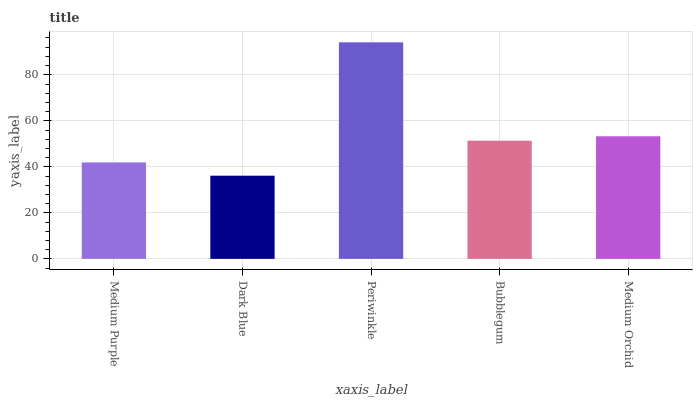Is Dark Blue the minimum?
Answer yes or no. Yes. Is Periwinkle the maximum?
Answer yes or no. Yes. Is Periwinkle the minimum?
Answer yes or no. No. Is Dark Blue the maximum?
Answer yes or no. No. Is Periwinkle greater than Dark Blue?
Answer yes or no. Yes. Is Dark Blue less than Periwinkle?
Answer yes or no. Yes. Is Dark Blue greater than Periwinkle?
Answer yes or no. No. Is Periwinkle less than Dark Blue?
Answer yes or no. No. Is Bubblegum the high median?
Answer yes or no. Yes. Is Bubblegum the low median?
Answer yes or no. Yes. Is Dark Blue the high median?
Answer yes or no. No. Is Medium Orchid the low median?
Answer yes or no. No. 